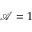Convert formula to latex. <formula><loc_0><loc_0><loc_500><loc_500>\mathcal { A } = 1</formula> 